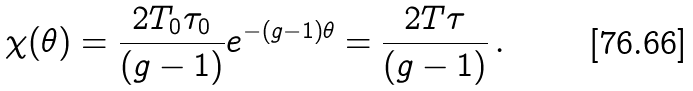Convert formula to latex. <formula><loc_0><loc_0><loc_500><loc_500>\chi ( \theta ) = \frac { 2 T _ { 0 } \tau _ { 0 } } { ( g - 1 ) } e ^ { - ( g - 1 ) \theta } = \frac { 2 T \tau } { ( g - 1 ) } \, .</formula> 